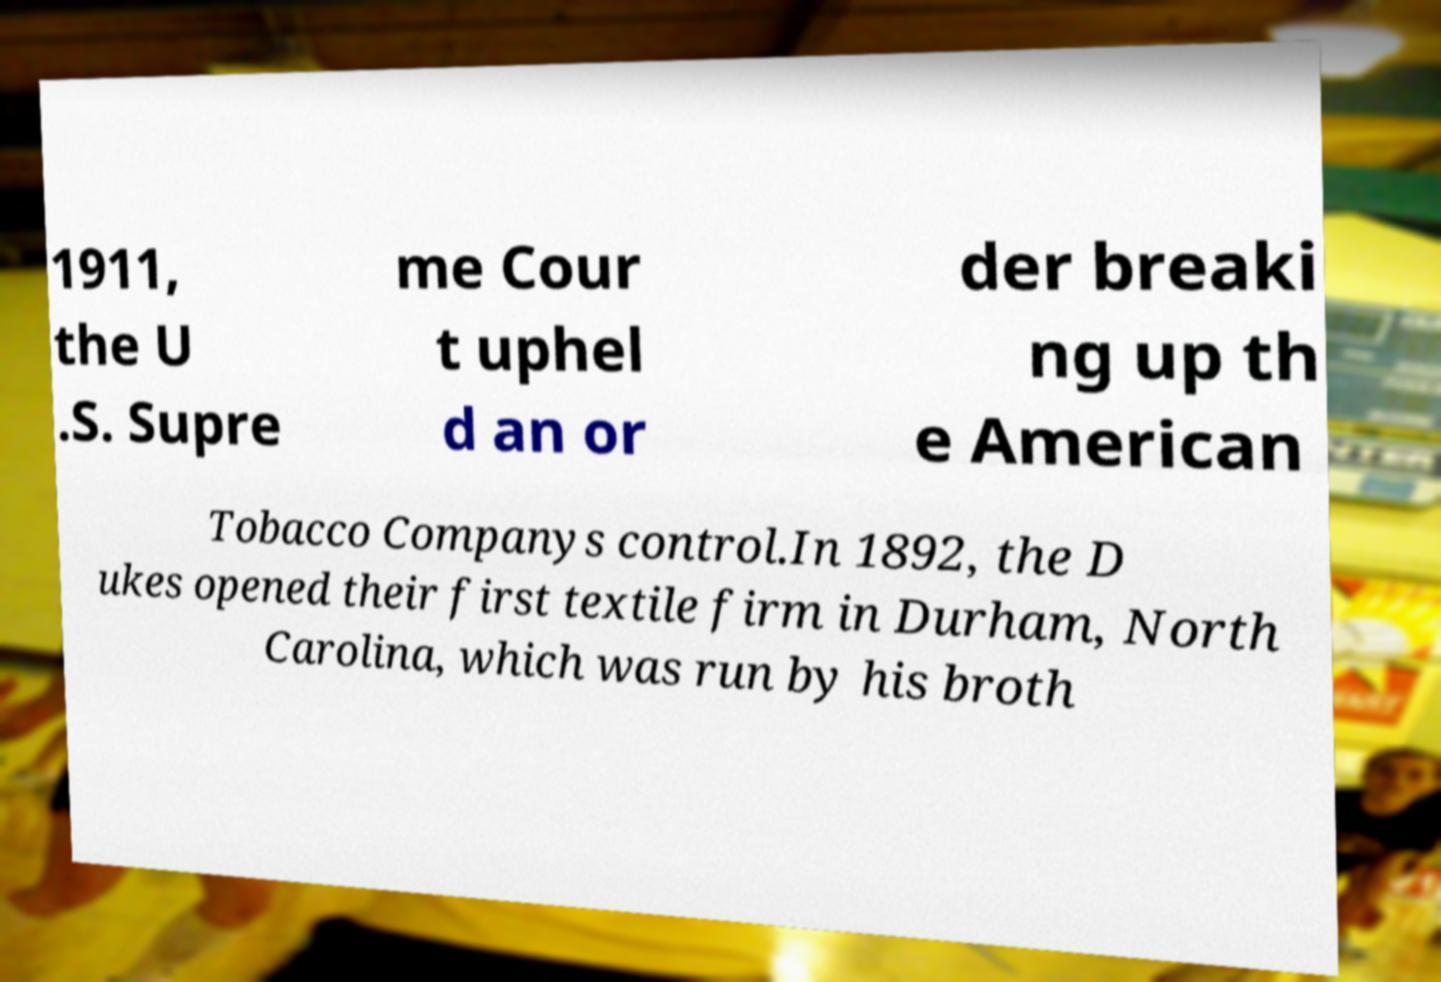Can you read and provide the text displayed in the image?This photo seems to have some interesting text. Can you extract and type it out for me? 1911, the U .S. Supre me Cour t uphel d an or der breaki ng up th e American Tobacco Companys control.In 1892, the D ukes opened their first textile firm in Durham, North Carolina, which was run by his broth 